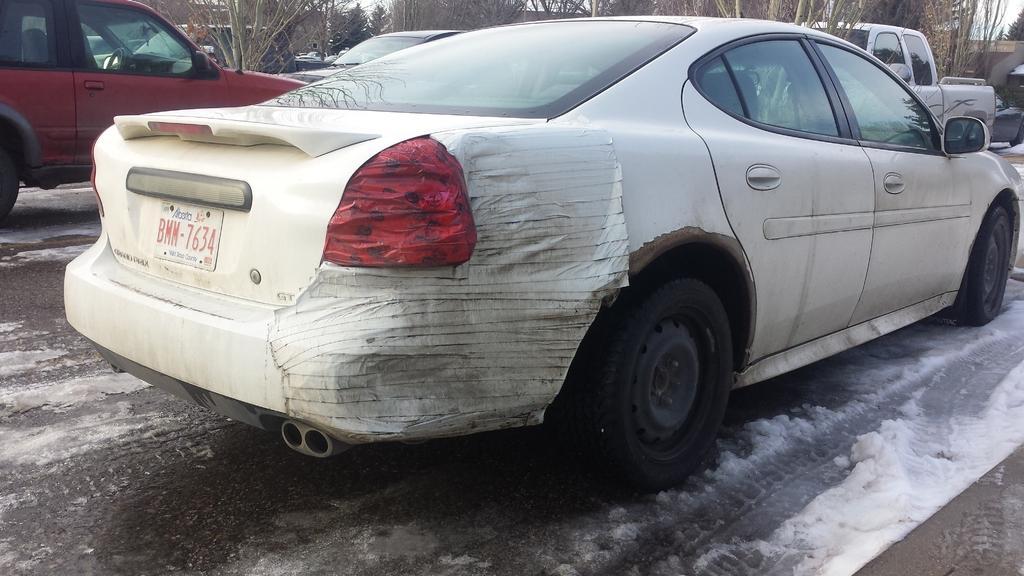Describe this image in one or two sentences. In this image we can see vehicles on the road. On the road there is snow. In the background we can see trees. 